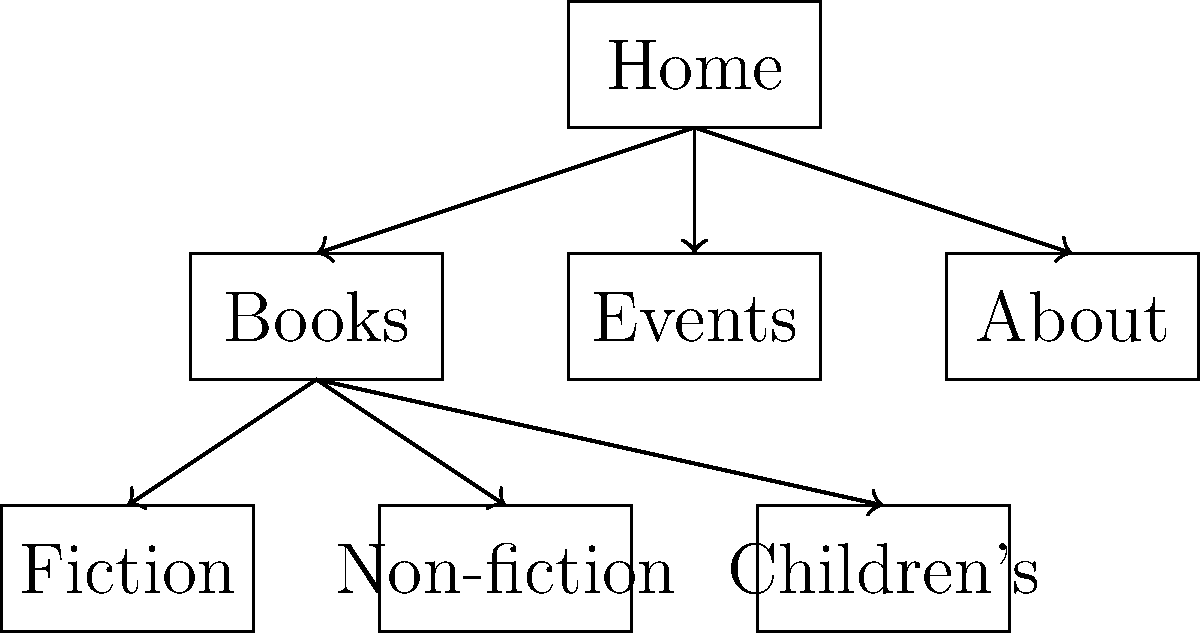Based on the sitemap structure shown in the diagram, which category of books is not directly linked under the "Books" section? To answer this question, let's analyze the sitemap structure step-by-step:

1. The top-level page is "Home", which is the root of the sitemap.

2. There are three main sections branching from "Home":
   a) Books
   b) Events
   c) About

3. The "Books" section has three subcategories:
   a) Fiction
   b) Non-fiction
   c) Children's

4. These subcategories are directly linked to the "Books" section.

5. Common categories that might be expected in a bookstore but are not shown in this sitemap include:
   - Young Adult
   - Biography
   - Self-help
   - Textbooks
   - Poetry

6. Among these, a significant category that is often separate from Children's books is "Young Adult" or "Teen" books.

Therefore, the category of books that is not directly linked under the "Books" section in this sitemap structure is Young Adult or Teen books.
Answer: Young Adult 